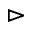Convert formula to latex. <formula><loc_0><loc_0><loc_500><loc_500>\vartriangleright</formula> 